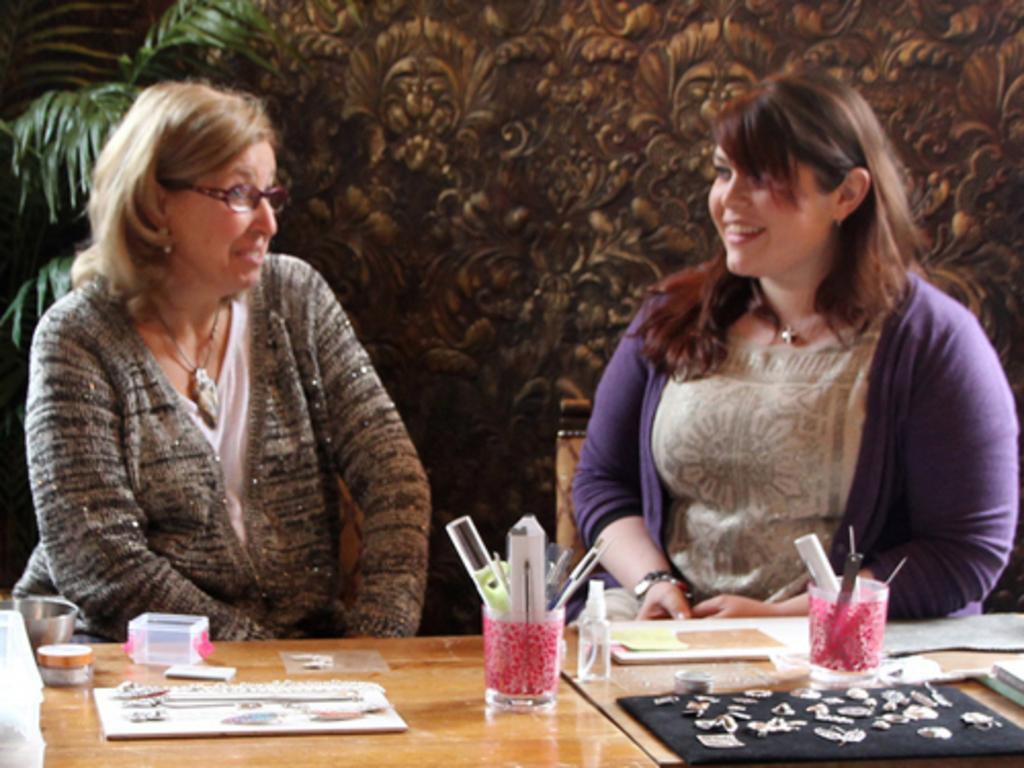Describe this image in one or two sentences. There are two ladies sitting in chair and talking each other and there is a table in front of them which consists of some objects on it. 